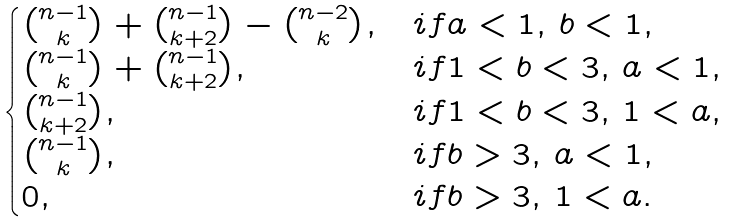<formula> <loc_0><loc_0><loc_500><loc_500>\begin{cases} \binom { n - 1 } { k } + \binom { n - 1 } { k + 2 } - \binom { n - 2 } { k } , & i f a < 1 , \, b < 1 , \\ \binom { n - 1 } { k } + \binom { n - 1 } { k + 2 } , & i f 1 < b < 3 , \, a < 1 , \\ \binom { n - 1 } { k + 2 } , & i f 1 < b < 3 , \, 1 < a , \\ \binom { n - 1 } { k } , & i f b > 3 , \, a < 1 , \\ 0 , & i f b > 3 , \, 1 < a . \end{cases}</formula> 